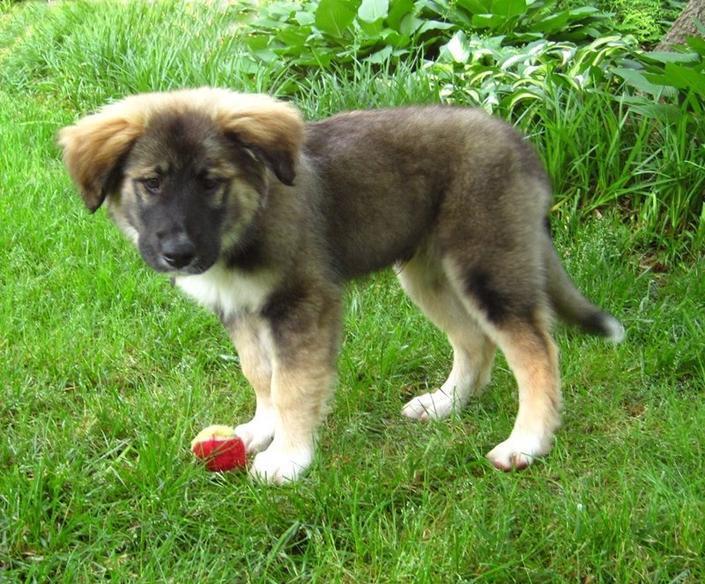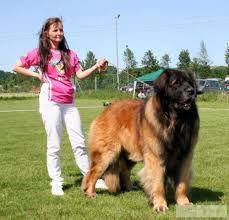The first image is the image on the left, the second image is the image on the right. For the images shown, is this caption "At least one image in the pair shows at least two mammals." true? Answer yes or no. Yes. The first image is the image on the left, the second image is the image on the right. Analyze the images presented: Is the assertion "Both images show a single adult dog looking left." valid? Answer yes or no. No. 